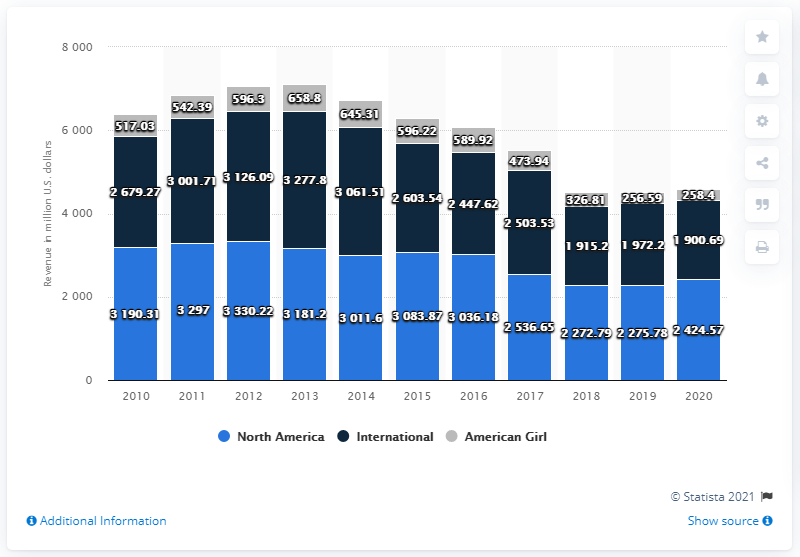List a handful of essential elements in this visual. Mattel's North America segment generated revenue of $24,24.57 in 2020. The revenue for American Girl is 402.21, and the difference between the highest and the smallest revenue is 402.21. American Girl achieved the highest revenue of $658.8 million in the past financial year. 